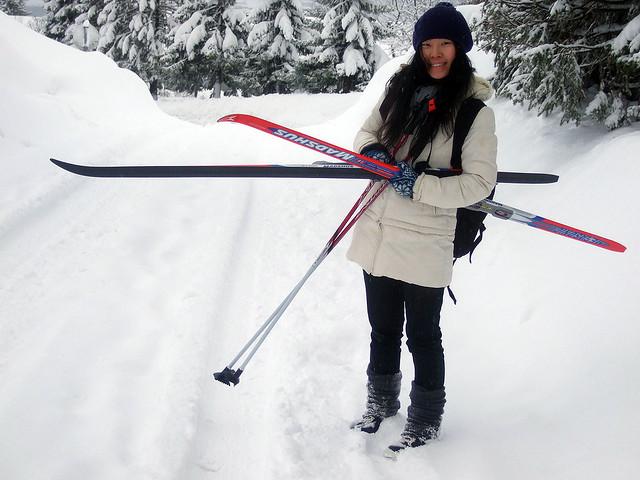Is this how skis should be carried?
Short answer required. No. Does this woman have long hair?
Short answer required. Yes. What is on the person's head?
Write a very short answer. Hat. 